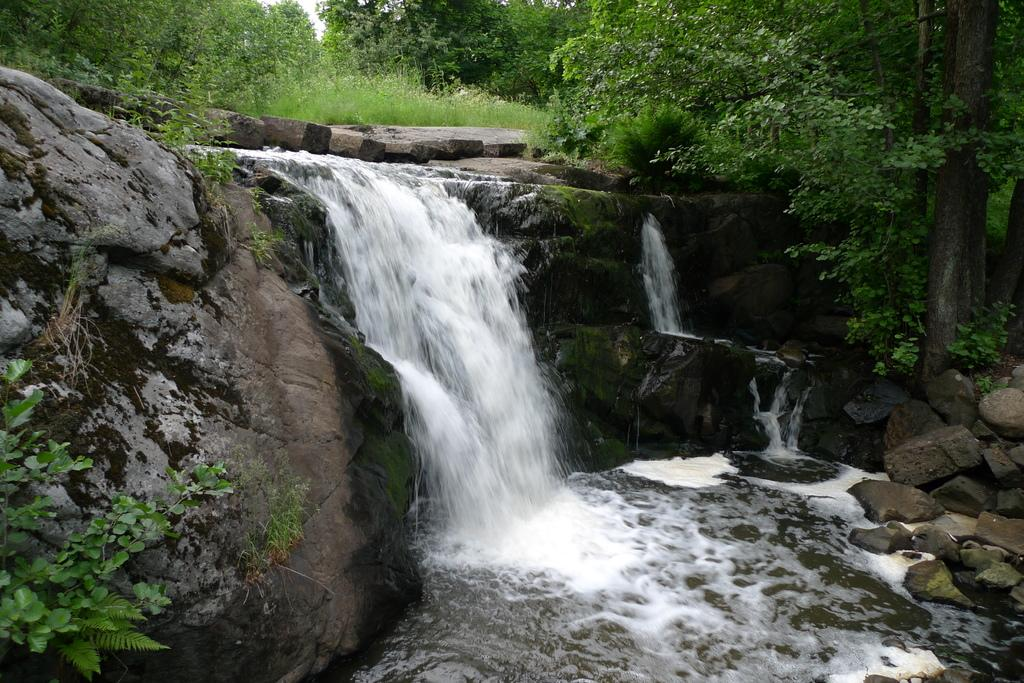What natural feature is the main subject of the image? There is a waterfall in the image. What can be seen to the right of the waterfall? There are rocks to the right of the waterfall. What type of vegetation is visible in the background of the image? There are trees in the background of the image. What is visible at the bottom of the image? There is water visible at the bottom of the image. Where is the lead pipe located in the image? There is no lead pipe present in the image. What type of grape can be seen growing near the waterfall? There are no grapes present in the image; it features a waterfall, rocks, trees, and water. 